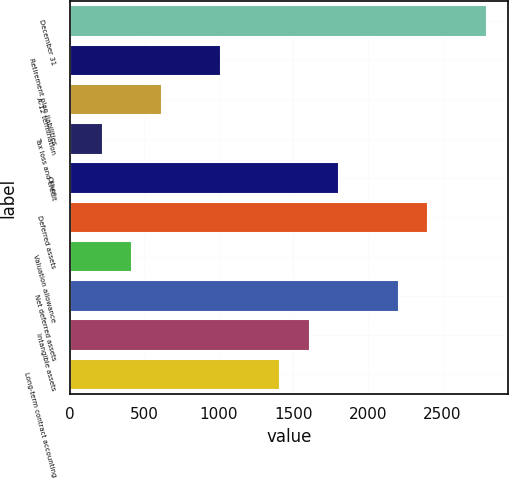Convert chart. <chart><loc_0><loc_0><loc_500><loc_500><bar_chart><fcel>December 31<fcel>Retirement plan liabilities<fcel>A-12 termination<fcel>Tax loss and credit<fcel>Other<fcel>Deferred assets<fcel>Valuation allowance<fcel>Net deferred assets<fcel>Intangible assets<fcel>Long-term contract accounting<nl><fcel>2800.2<fcel>1015.5<fcel>618.9<fcel>222.3<fcel>1808.7<fcel>2403.6<fcel>420.6<fcel>2205.3<fcel>1610.4<fcel>1412.1<nl></chart> 